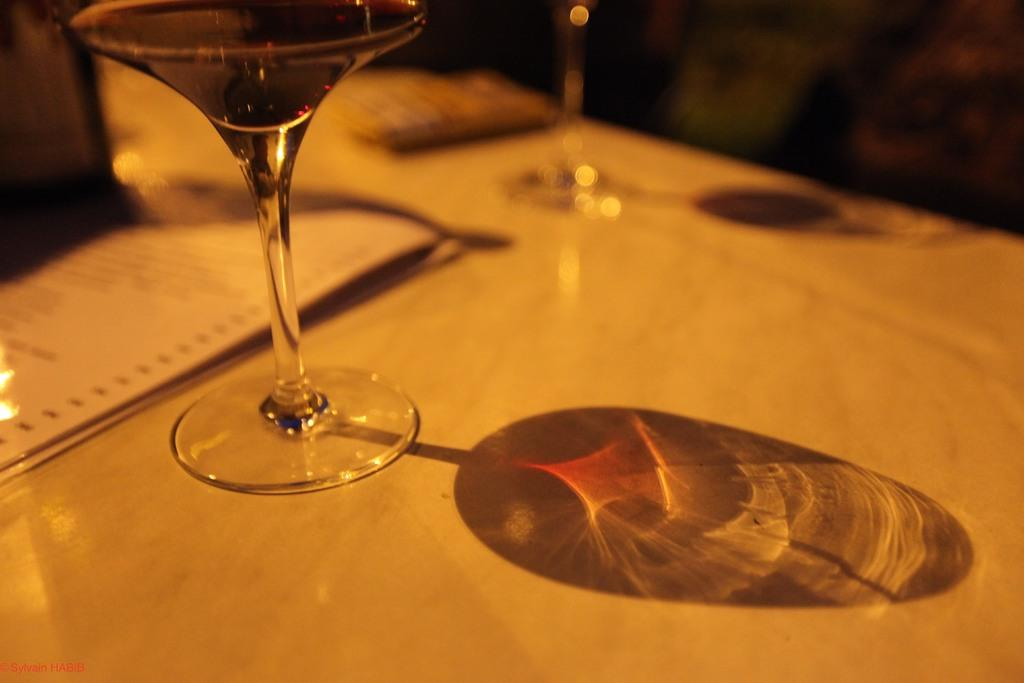What objects are on the platform in the image? There are glasses and papers on the platform. Can you describe the glasses on the platform? The glasses on the platform are likely used for drinking or observing. What else is on the platform besides the glasses? There are papers on the platform. What type of lumber is being used to build the platform in the image? There is no information about the construction of the platform or the type of lumber used in the image. How does the presence of glasses and papers on the platform make the person feel in the image? The image does not provide any information about the person's feelings or emotions. 